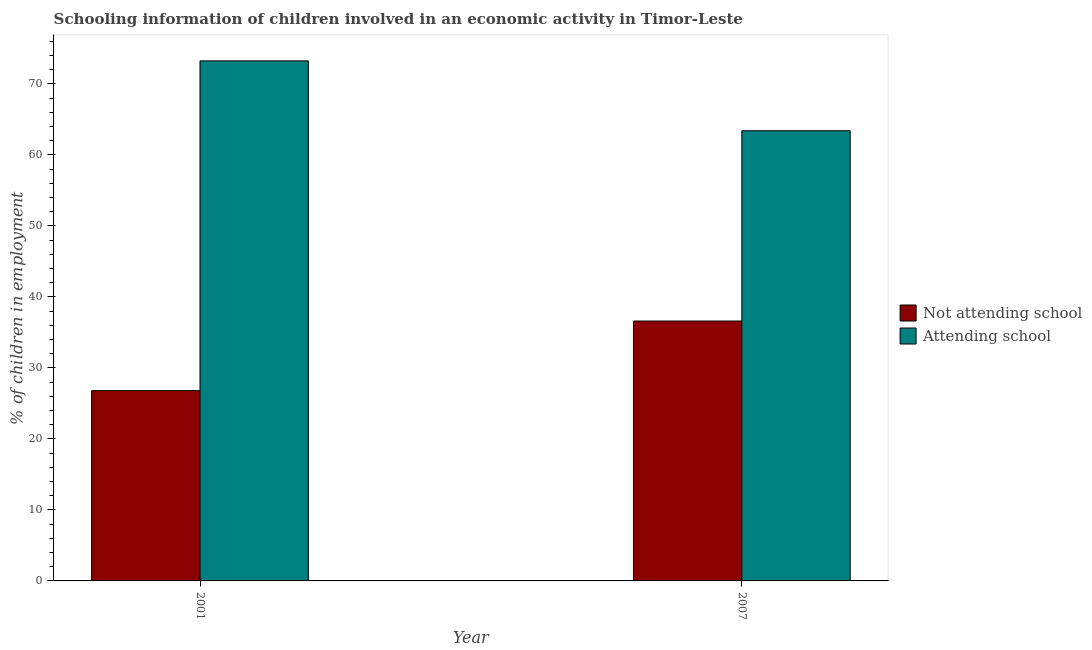How many different coloured bars are there?
Offer a terse response. 2. How many groups of bars are there?
Your answer should be very brief. 2. Are the number of bars on each tick of the X-axis equal?
Provide a succinct answer. Yes. How many bars are there on the 1st tick from the left?
Give a very brief answer. 2. How many bars are there on the 1st tick from the right?
Your answer should be compact. 2. In how many cases, is the number of bars for a given year not equal to the number of legend labels?
Your response must be concise. 0. What is the percentage of employed children who are not attending school in 2007?
Ensure brevity in your answer.  36.6. Across all years, what is the maximum percentage of employed children who are attending school?
Make the answer very short. 73.24. Across all years, what is the minimum percentage of employed children who are attending school?
Offer a very short reply. 63.4. In which year was the percentage of employed children who are attending school maximum?
Offer a terse response. 2001. What is the total percentage of employed children who are not attending school in the graph?
Provide a short and direct response. 63.4. What is the difference between the percentage of employed children who are not attending school in 2001 and that in 2007?
Offer a very short reply. -9.8. What is the difference between the percentage of employed children who are not attending school in 2001 and the percentage of employed children who are attending school in 2007?
Ensure brevity in your answer.  -9.8. What is the average percentage of employed children who are attending school per year?
Ensure brevity in your answer.  68.32. In the year 2007, what is the difference between the percentage of employed children who are not attending school and percentage of employed children who are attending school?
Your response must be concise. 0. In how many years, is the percentage of employed children who are attending school greater than 62 %?
Your response must be concise. 2. What is the ratio of the percentage of employed children who are attending school in 2001 to that in 2007?
Your response must be concise. 1.16. Is the percentage of employed children who are not attending school in 2001 less than that in 2007?
Provide a succinct answer. Yes. In how many years, is the percentage of employed children who are attending school greater than the average percentage of employed children who are attending school taken over all years?
Your answer should be very brief. 1. What does the 2nd bar from the left in 2001 represents?
Offer a terse response. Attending school. What does the 2nd bar from the right in 2007 represents?
Your response must be concise. Not attending school. Are all the bars in the graph horizontal?
Your answer should be very brief. No. How many years are there in the graph?
Provide a succinct answer. 2. What is the difference between two consecutive major ticks on the Y-axis?
Provide a short and direct response. 10. Are the values on the major ticks of Y-axis written in scientific E-notation?
Make the answer very short. No. Does the graph contain any zero values?
Offer a terse response. No. Does the graph contain grids?
Keep it short and to the point. No. Where does the legend appear in the graph?
Your answer should be very brief. Center right. What is the title of the graph?
Keep it short and to the point. Schooling information of children involved in an economic activity in Timor-Leste. What is the label or title of the X-axis?
Your answer should be very brief. Year. What is the label or title of the Y-axis?
Offer a very short reply. % of children in employment. What is the % of children in employment of Not attending school in 2001?
Make the answer very short. 26.8. What is the % of children in employment in Attending school in 2001?
Your answer should be very brief. 73.24. What is the % of children in employment in Not attending school in 2007?
Your answer should be very brief. 36.6. What is the % of children in employment in Attending school in 2007?
Ensure brevity in your answer.  63.4. Across all years, what is the maximum % of children in employment in Not attending school?
Your response must be concise. 36.6. Across all years, what is the maximum % of children in employment of Attending school?
Offer a very short reply. 73.24. Across all years, what is the minimum % of children in employment of Not attending school?
Provide a short and direct response. 26.8. Across all years, what is the minimum % of children in employment in Attending school?
Offer a terse response. 63.4. What is the total % of children in employment in Not attending school in the graph?
Give a very brief answer. 63.4. What is the total % of children in employment in Attending school in the graph?
Your response must be concise. 136.64. What is the difference between the % of children in employment in Not attending school in 2001 and that in 2007?
Provide a succinct answer. -9.8. What is the difference between the % of children in employment of Attending school in 2001 and that in 2007?
Offer a terse response. 9.84. What is the difference between the % of children in employment in Not attending school in 2001 and the % of children in employment in Attending school in 2007?
Give a very brief answer. -36.6. What is the average % of children in employment of Not attending school per year?
Your answer should be very brief. 31.7. What is the average % of children in employment in Attending school per year?
Provide a succinct answer. 68.32. In the year 2001, what is the difference between the % of children in employment in Not attending school and % of children in employment in Attending school?
Ensure brevity in your answer.  -46.44. In the year 2007, what is the difference between the % of children in employment in Not attending school and % of children in employment in Attending school?
Provide a succinct answer. -26.8. What is the ratio of the % of children in employment in Not attending school in 2001 to that in 2007?
Ensure brevity in your answer.  0.73. What is the ratio of the % of children in employment in Attending school in 2001 to that in 2007?
Your answer should be very brief. 1.16. What is the difference between the highest and the second highest % of children in employment in Not attending school?
Make the answer very short. 9.8. What is the difference between the highest and the second highest % of children in employment in Attending school?
Your answer should be compact. 9.84. What is the difference between the highest and the lowest % of children in employment of Attending school?
Provide a succinct answer. 9.84. 